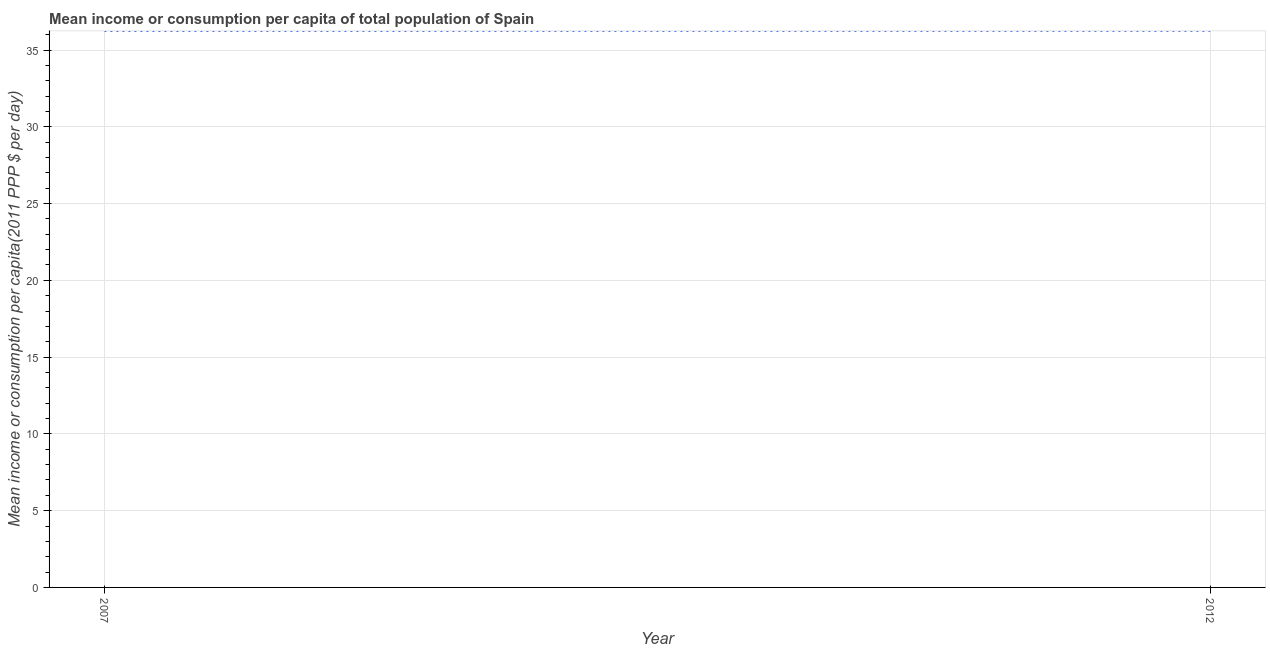What is the mean income or consumption in 2012?
Offer a terse response. 36.25. Across all years, what is the maximum mean income or consumption?
Provide a short and direct response. 36.25. Across all years, what is the minimum mean income or consumption?
Offer a very short reply. 36.25. In which year was the mean income or consumption maximum?
Your answer should be very brief. 2012. In which year was the mean income or consumption minimum?
Provide a short and direct response. 2007. What is the sum of the mean income or consumption?
Keep it short and to the point. 72.5. What is the difference between the mean income or consumption in 2007 and 2012?
Give a very brief answer. -0.01. What is the average mean income or consumption per year?
Make the answer very short. 36.25. What is the median mean income or consumption?
Give a very brief answer. 36.25. Do a majority of the years between 2012 and 2007 (inclusive) have mean income or consumption greater than 15 $?
Make the answer very short. No. What is the ratio of the mean income or consumption in 2007 to that in 2012?
Provide a short and direct response. 1. In how many years, is the mean income or consumption greater than the average mean income or consumption taken over all years?
Your answer should be very brief. 1. Does the mean income or consumption monotonically increase over the years?
Provide a succinct answer. Yes. Are the values on the major ticks of Y-axis written in scientific E-notation?
Keep it short and to the point. No. Does the graph contain grids?
Your answer should be compact. Yes. What is the title of the graph?
Keep it short and to the point. Mean income or consumption per capita of total population of Spain. What is the label or title of the Y-axis?
Provide a succinct answer. Mean income or consumption per capita(2011 PPP $ per day). What is the Mean income or consumption per capita(2011 PPP $ per day) of 2007?
Your answer should be very brief. 36.25. What is the Mean income or consumption per capita(2011 PPP $ per day) of 2012?
Offer a terse response. 36.25. What is the difference between the Mean income or consumption per capita(2011 PPP $ per day) in 2007 and 2012?
Keep it short and to the point. -0.01. What is the ratio of the Mean income or consumption per capita(2011 PPP $ per day) in 2007 to that in 2012?
Your response must be concise. 1. 